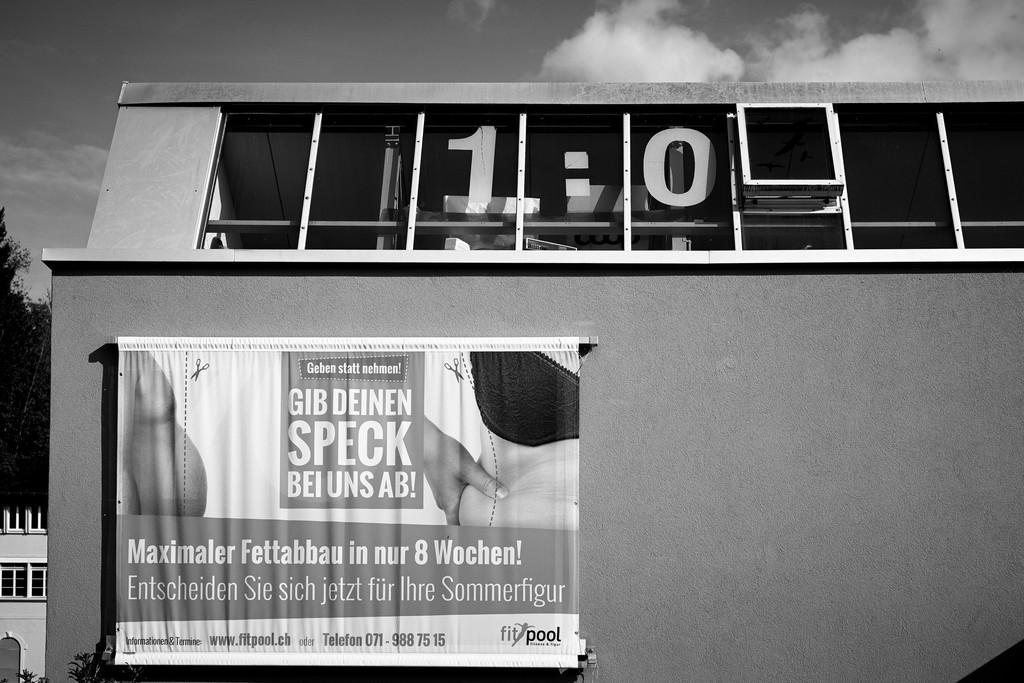What type of structure is present in the image? There is a building in the image. What is attached to the building? There is a banner on the building. What can be seen in the distance behind the building? There are houses and trees visible in the background of the image. What type of lettuce is growing on the roof of the building in the image? There is no lettuce visible on the roof of the building in the image. 